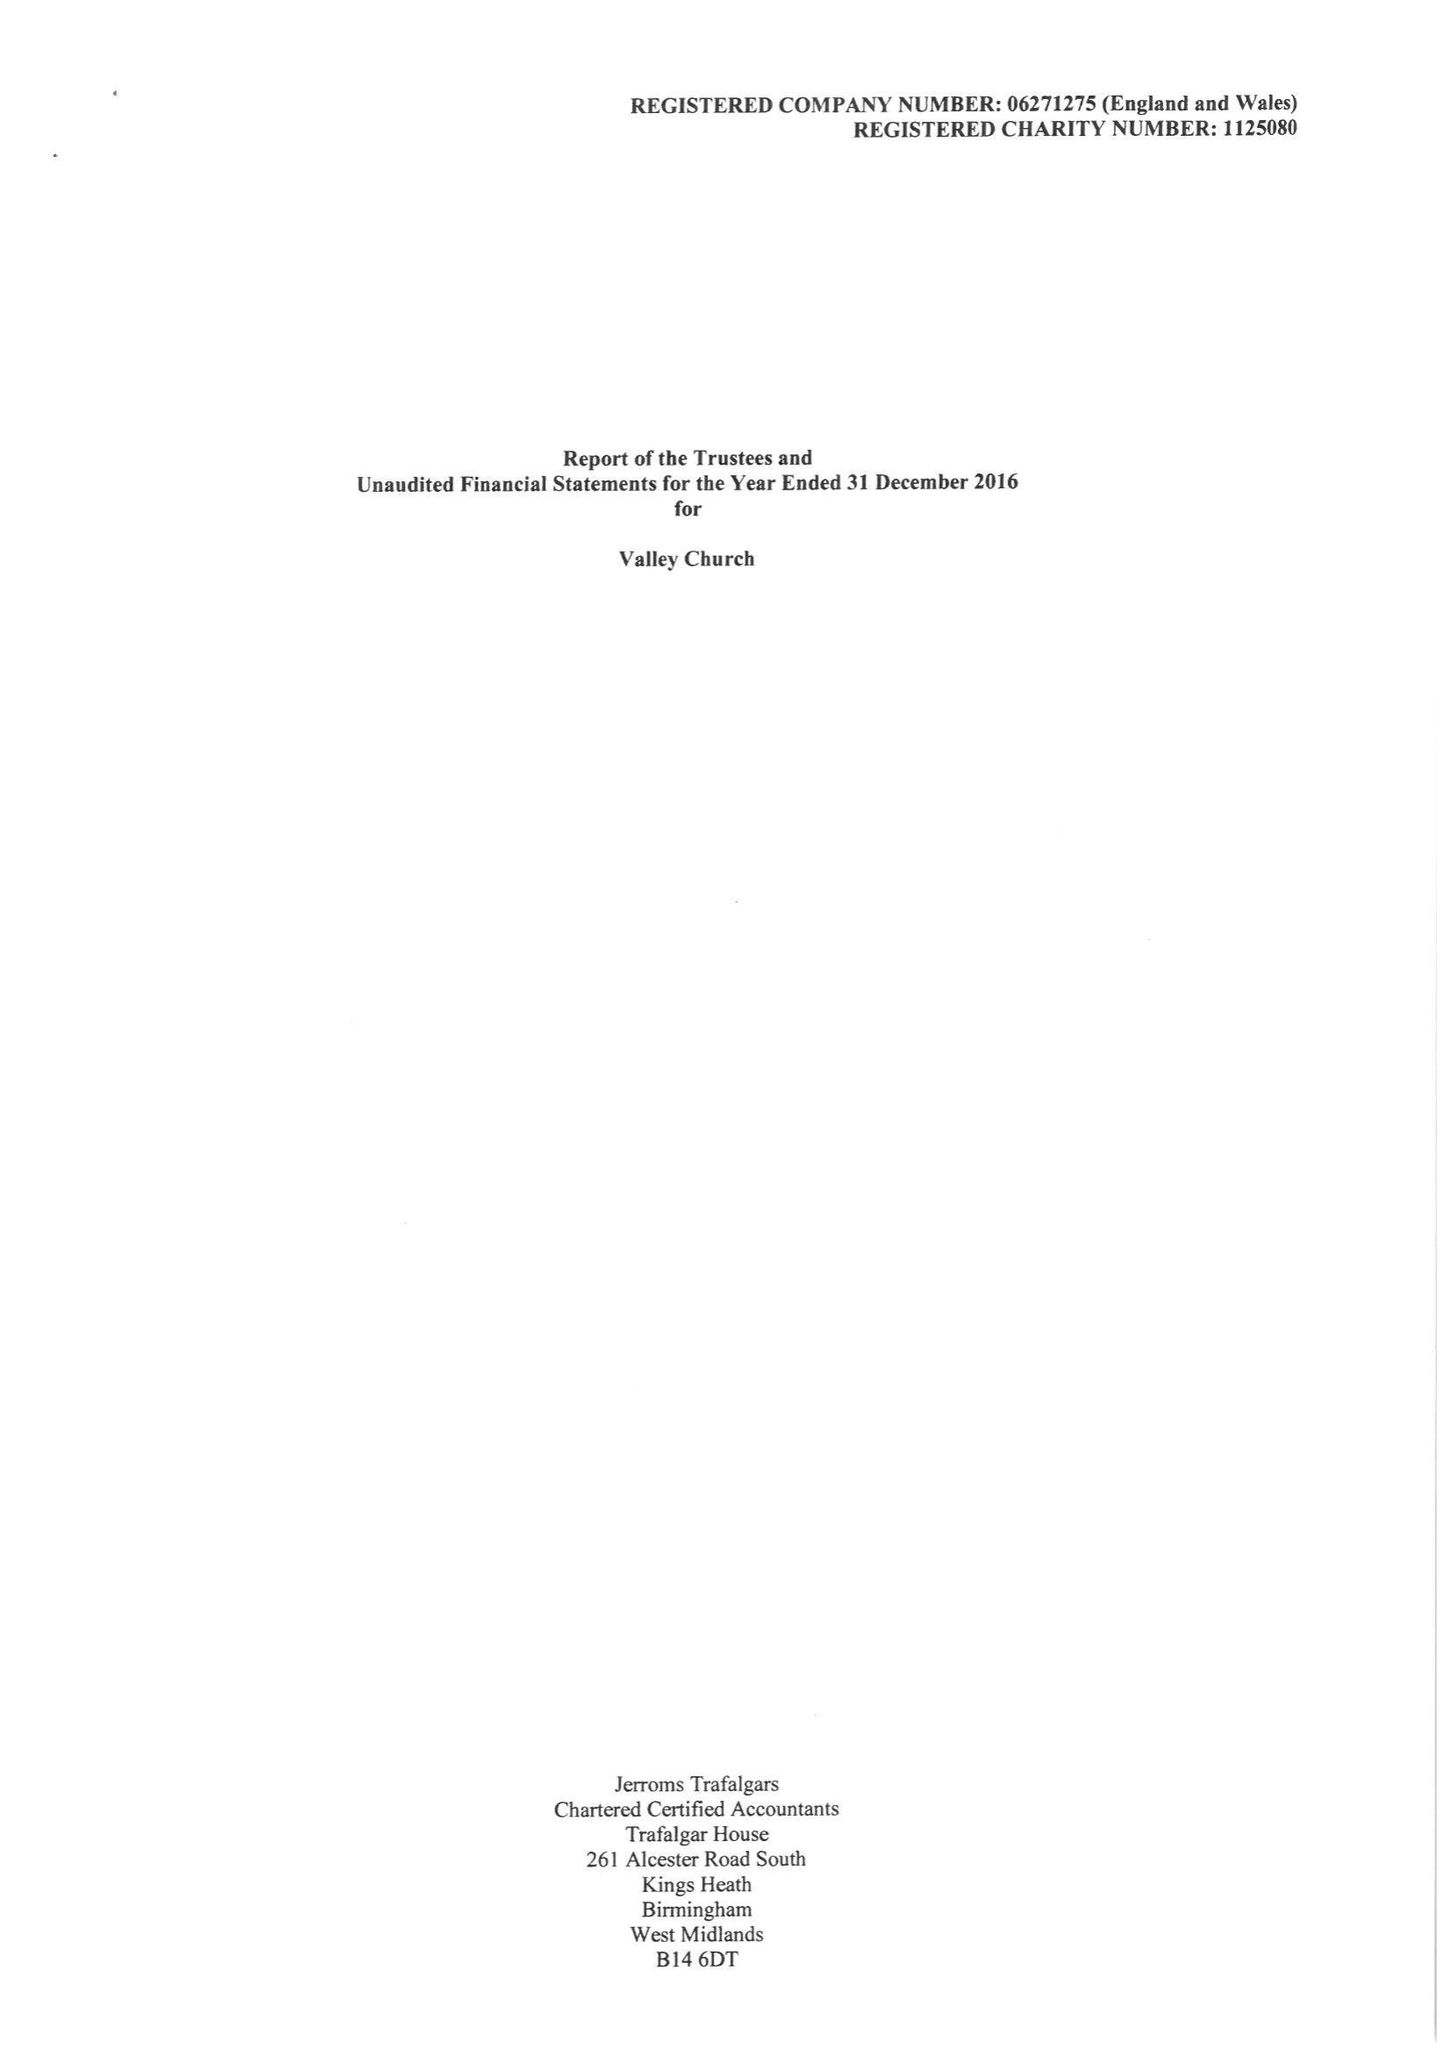What is the value for the spending_annually_in_british_pounds?
Answer the question using a single word or phrase. 243297.00 